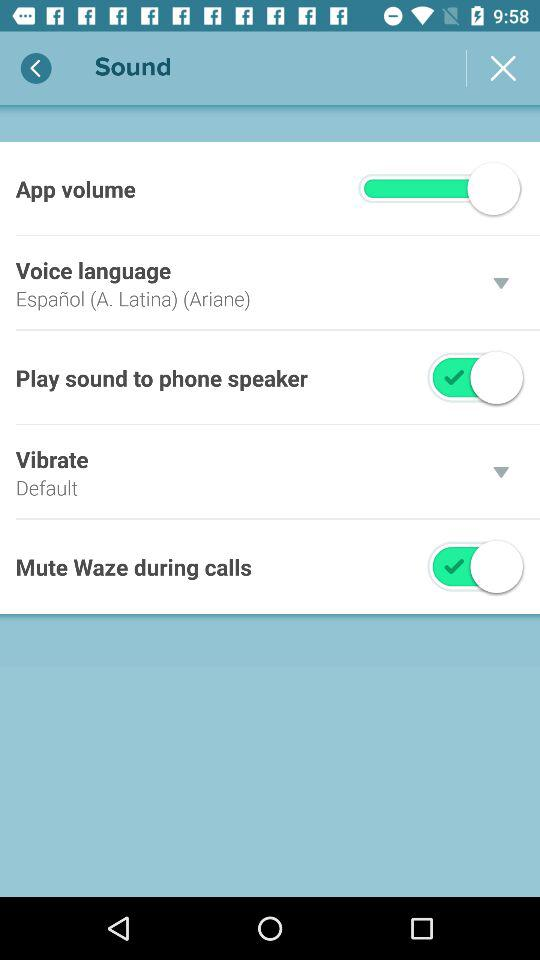How many of the sound settings have a switch?
Answer the question using a single word or phrase. 3 